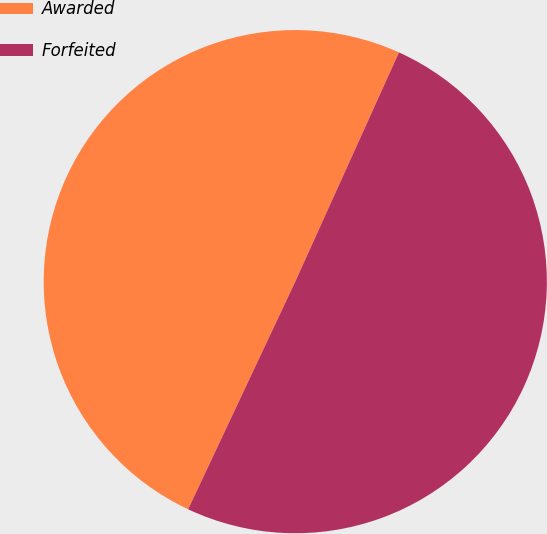Convert chart. <chart><loc_0><loc_0><loc_500><loc_500><pie_chart><fcel>Awarded<fcel>Forfeited<nl><fcel>49.76%<fcel>50.24%<nl></chart> 